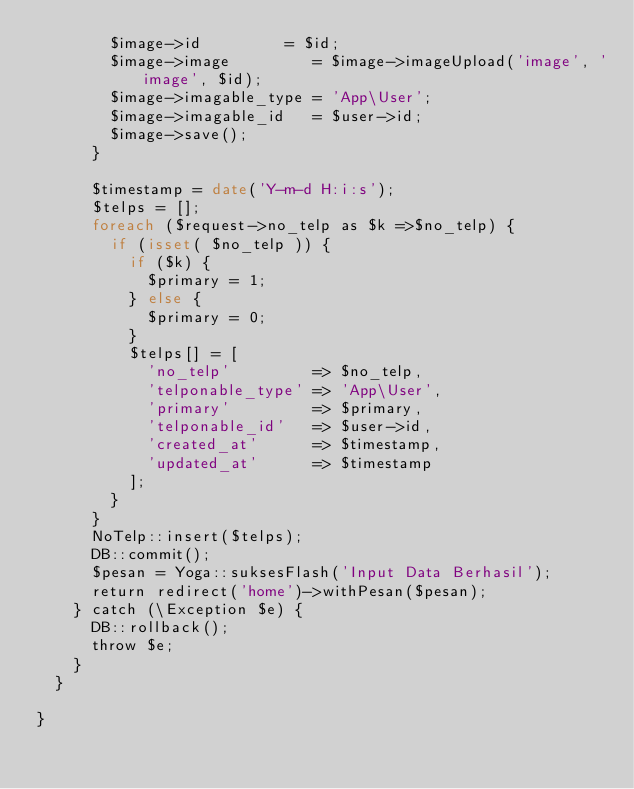<code> <loc_0><loc_0><loc_500><loc_500><_PHP_>				$image->id         = $id;
				$image->image         = $image->imageUpload('image', 'image', $id);
				$image->imagable_type = 'App\User';
				$image->imagable_id   = $user->id;
				$image->save();
			}

			$timestamp = date('Y-m-d H:i:s');
			$telps = [];
			foreach ($request->no_telp as $k =>$no_telp) {
				if (isset( $no_telp )) {
					if ($k) {
						$primary = 1;
					} else {
						$primary = 0;
					}
					$telps[] = [
						'no_telp'         => $no_telp,
						'telponable_type' => 'App\User',
						'primary'         => $primary,
						'telponable_id'   => $user->id,
						'created_at'      => $timestamp,
						'updated_at'      => $timestamp
					];
				}
			}
			NoTelp::insert($telps);
			DB::commit();
			$pesan = Yoga::suksesFlash('Input Data Berhasil');
			return redirect('home')->withPesan($pesan);
		} catch (\Exception $e) {
			DB::rollback();
			throw $e;
		}
	}
	
}
</code> 